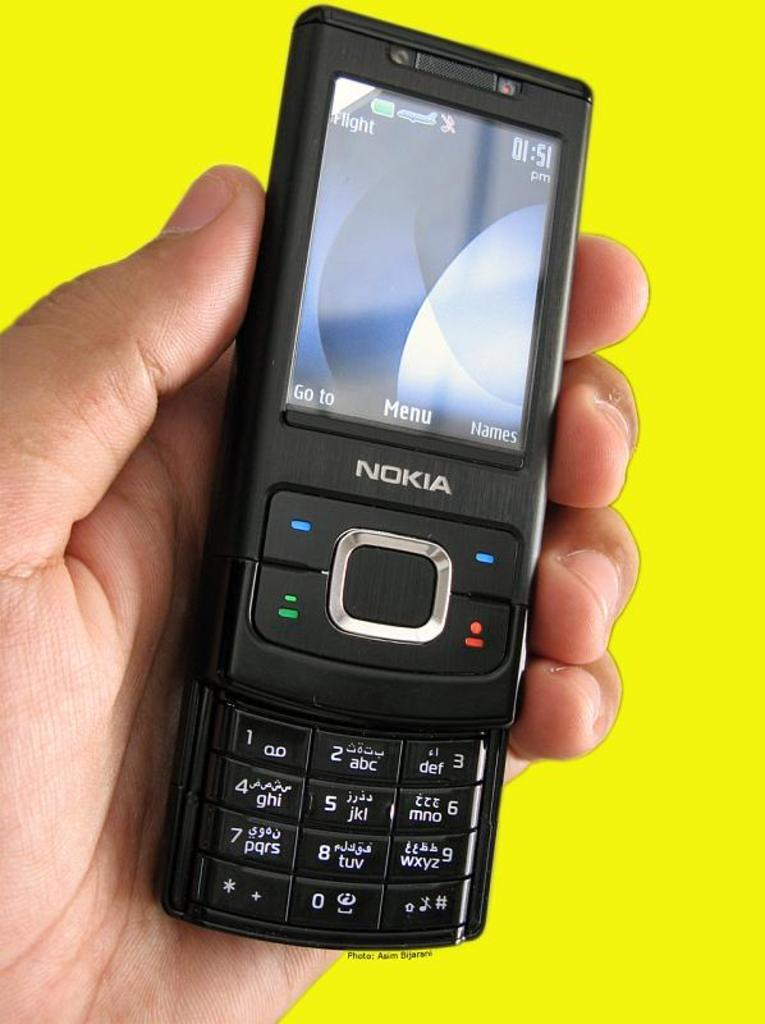<image>
Share a concise interpretation of the image provided. A person is holding a slide up Nokia mobile phone. 